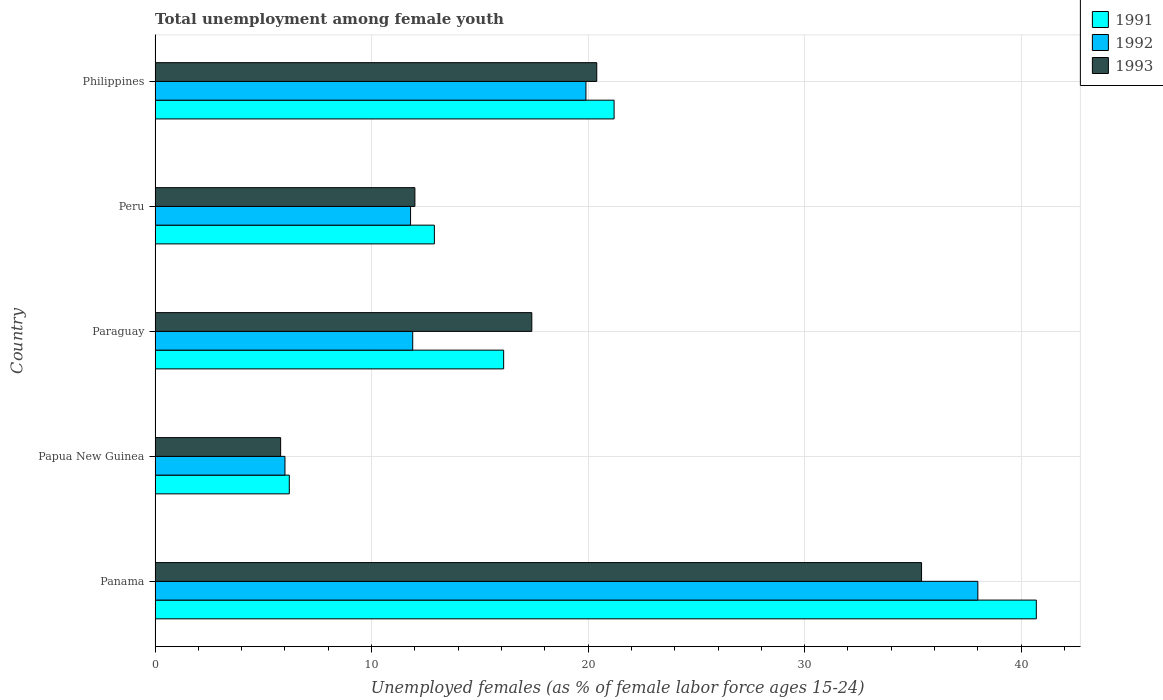How many different coloured bars are there?
Your answer should be compact. 3. How many groups of bars are there?
Your response must be concise. 5. Are the number of bars on each tick of the Y-axis equal?
Your answer should be very brief. Yes. How many bars are there on the 1st tick from the top?
Make the answer very short. 3. What is the label of the 2nd group of bars from the top?
Offer a very short reply. Peru. In how many cases, is the number of bars for a given country not equal to the number of legend labels?
Give a very brief answer. 0. What is the percentage of unemployed females in in 1992 in Paraguay?
Your response must be concise. 11.9. Across all countries, what is the maximum percentage of unemployed females in in 1991?
Your response must be concise. 40.7. Across all countries, what is the minimum percentage of unemployed females in in 1993?
Keep it short and to the point. 5.8. In which country was the percentage of unemployed females in in 1991 maximum?
Ensure brevity in your answer.  Panama. In which country was the percentage of unemployed females in in 1992 minimum?
Your answer should be compact. Papua New Guinea. What is the total percentage of unemployed females in in 1993 in the graph?
Offer a very short reply. 91. What is the difference between the percentage of unemployed females in in 1992 in Paraguay and that in Peru?
Offer a terse response. 0.1. What is the difference between the percentage of unemployed females in in 1992 in Peru and the percentage of unemployed females in in 1991 in Philippines?
Keep it short and to the point. -9.4. What is the average percentage of unemployed females in in 1991 per country?
Your response must be concise. 19.42. What is the difference between the percentage of unemployed females in in 1992 and percentage of unemployed females in in 1993 in Philippines?
Your answer should be very brief. -0.5. In how many countries, is the percentage of unemployed females in in 1993 greater than 16 %?
Make the answer very short. 3. What is the ratio of the percentage of unemployed females in in 1992 in Panama to that in Philippines?
Provide a short and direct response. 1.91. Is the percentage of unemployed females in in 1993 in Paraguay less than that in Peru?
Provide a succinct answer. No. Is the difference between the percentage of unemployed females in in 1992 in Paraguay and Peru greater than the difference between the percentage of unemployed females in in 1993 in Paraguay and Peru?
Make the answer very short. No. What is the difference between the highest and the second highest percentage of unemployed females in in 1991?
Offer a very short reply. 19.5. What is the difference between the highest and the lowest percentage of unemployed females in in 1993?
Your answer should be compact. 29.6. In how many countries, is the percentage of unemployed females in in 1993 greater than the average percentage of unemployed females in in 1993 taken over all countries?
Offer a terse response. 2. Is the sum of the percentage of unemployed females in in 1992 in Papua New Guinea and Philippines greater than the maximum percentage of unemployed females in in 1991 across all countries?
Provide a short and direct response. No. What does the 2nd bar from the top in Panama represents?
Your answer should be compact. 1992. Is it the case that in every country, the sum of the percentage of unemployed females in in 1991 and percentage of unemployed females in in 1992 is greater than the percentage of unemployed females in in 1993?
Provide a succinct answer. Yes. Are the values on the major ticks of X-axis written in scientific E-notation?
Make the answer very short. No. Does the graph contain grids?
Keep it short and to the point. Yes. How many legend labels are there?
Your response must be concise. 3. What is the title of the graph?
Your answer should be compact. Total unemployment among female youth. What is the label or title of the X-axis?
Keep it short and to the point. Unemployed females (as % of female labor force ages 15-24). What is the label or title of the Y-axis?
Your answer should be compact. Country. What is the Unemployed females (as % of female labor force ages 15-24) of 1991 in Panama?
Your answer should be very brief. 40.7. What is the Unemployed females (as % of female labor force ages 15-24) in 1992 in Panama?
Ensure brevity in your answer.  38. What is the Unemployed females (as % of female labor force ages 15-24) of 1993 in Panama?
Ensure brevity in your answer.  35.4. What is the Unemployed females (as % of female labor force ages 15-24) in 1991 in Papua New Guinea?
Provide a succinct answer. 6.2. What is the Unemployed females (as % of female labor force ages 15-24) in 1993 in Papua New Guinea?
Your answer should be compact. 5.8. What is the Unemployed females (as % of female labor force ages 15-24) in 1991 in Paraguay?
Your response must be concise. 16.1. What is the Unemployed females (as % of female labor force ages 15-24) in 1992 in Paraguay?
Ensure brevity in your answer.  11.9. What is the Unemployed females (as % of female labor force ages 15-24) in 1993 in Paraguay?
Offer a terse response. 17.4. What is the Unemployed females (as % of female labor force ages 15-24) of 1991 in Peru?
Ensure brevity in your answer.  12.9. What is the Unemployed females (as % of female labor force ages 15-24) of 1992 in Peru?
Offer a terse response. 11.8. What is the Unemployed females (as % of female labor force ages 15-24) in 1991 in Philippines?
Make the answer very short. 21.2. What is the Unemployed females (as % of female labor force ages 15-24) of 1992 in Philippines?
Offer a very short reply. 19.9. What is the Unemployed females (as % of female labor force ages 15-24) of 1993 in Philippines?
Ensure brevity in your answer.  20.4. Across all countries, what is the maximum Unemployed females (as % of female labor force ages 15-24) in 1991?
Your response must be concise. 40.7. Across all countries, what is the maximum Unemployed females (as % of female labor force ages 15-24) in 1992?
Give a very brief answer. 38. Across all countries, what is the maximum Unemployed females (as % of female labor force ages 15-24) of 1993?
Offer a very short reply. 35.4. Across all countries, what is the minimum Unemployed females (as % of female labor force ages 15-24) of 1991?
Keep it short and to the point. 6.2. Across all countries, what is the minimum Unemployed females (as % of female labor force ages 15-24) of 1993?
Make the answer very short. 5.8. What is the total Unemployed females (as % of female labor force ages 15-24) in 1991 in the graph?
Keep it short and to the point. 97.1. What is the total Unemployed females (as % of female labor force ages 15-24) in 1992 in the graph?
Make the answer very short. 87.6. What is the total Unemployed females (as % of female labor force ages 15-24) in 1993 in the graph?
Provide a short and direct response. 91. What is the difference between the Unemployed females (as % of female labor force ages 15-24) in 1991 in Panama and that in Papua New Guinea?
Offer a very short reply. 34.5. What is the difference between the Unemployed females (as % of female labor force ages 15-24) in 1992 in Panama and that in Papua New Guinea?
Ensure brevity in your answer.  32. What is the difference between the Unemployed females (as % of female labor force ages 15-24) in 1993 in Panama and that in Papua New Guinea?
Ensure brevity in your answer.  29.6. What is the difference between the Unemployed females (as % of female labor force ages 15-24) of 1991 in Panama and that in Paraguay?
Offer a very short reply. 24.6. What is the difference between the Unemployed females (as % of female labor force ages 15-24) in 1992 in Panama and that in Paraguay?
Your answer should be compact. 26.1. What is the difference between the Unemployed females (as % of female labor force ages 15-24) in 1993 in Panama and that in Paraguay?
Make the answer very short. 18. What is the difference between the Unemployed females (as % of female labor force ages 15-24) of 1991 in Panama and that in Peru?
Ensure brevity in your answer.  27.8. What is the difference between the Unemployed females (as % of female labor force ages 15-24) of 1992 in Panama and that in Peru?
Offer a very short reply. 26.2. What is the difference between the Unemployed females (as % of female labor force ages 15-24) in 1993 in Panama and that in Peru?
Make the answer very short. 23.4. What is the difference between the Unemployed females (as % of female labor force ages 15-24) of 1991 in Papua New Guinea and that in Paraguay?
Ensure brevity in your answer.  -9.9. What is the difference between the Unemployed females (as % of female labor force ages 15-24) of 1992 in Papua New Guinea and that in Paraguay?
Your answer should be compact. -5.9. What is the difference between the Unemployed females (as % of female labor force ages 15-24) in 1993 in Papua New Guinea and that in Paraguay?
Provide a succinct answer. -11.6. What is the difference between the Unemployed females (as % of female labor force ages 15-24) of 1992 in Papua New Guinea and that in Peru?
Make the answer very short. -5.8. What is the difference between the Unemployed females (as % of female labor force ages 15-24) in 1993 in Papua New Guinea and that in Peru?
Your response must be concise. -6.2. What is the difference between the Unemployed females (as % of female labor force ages 15-24) in 1991 in Papua New Guinea and that in Philippines?
Your response must be concise. -15. What is the difference between the Unemployed females (as % of female labor force ages 15-24) of 1993 in Papua New Guinea and that in Philippines?
Make the answer very short. -14.6. What is the difference between the Unemployed females (as % of female labor force ages 15-24) in 1991 in Paraguay and that in Peru?
Offer a very short reply. 3.2. What is the difference between the Unemployed females (as % of female labor force ages 15-24) in 1993 in Paraguay and that in Peru?
Keep it short and to the point. 5.4. What is the difference between the Unemployed females (as % of female labor force ages 15-24) of 1991 in Paraguay and that in Philippines?
Your answer should be compact. -5.1. What is the difference between the Unemployed females (as % of female labor force ages 15-24) in 1993 in Paraguay and that in Philippines?
Your answer should be very brief. -3. What is the difference between the Unemployed females (as % of female labor force ages 15-24) of 1991 in Peru and that in Philippines?
Keep it short and to the point. -8.3. What is the difference between the Unemployed females (as % of female labor force ages 15-24) in 1992 in Peru and that in Philippines?
Ensure brevity in your answer.  -8.1. What is the difference between the Unemployed females (as % of female labor force ages 15-24) in 1993 in Peru and that in Philippines?
Provide a short and direct response. -8.4. What is the difference between the Unemployed females (as % of female labor force ages 15-24) of 1991 in Panama and the Unemployed females (as % of female labor force ages 15-24) of 1992 in Papua New Guinea?
Your response must be concise. 34.7. What is the difference between the Unemployed females (as % of female labor force ages 15-24) of 1991 in Panama and the Unemployed females (as % of female labor force ages 15-24) of 1993 in Papua New Guinea?
Your answer should be very brief. 34.9. What is the difference between the Unemployed females (as % of female labor force ages 15-24) of 1992 in Panama and the Unemployed females (as % of female labor force ages 15-24) of 1993 in Papua New Guinea?
Your response must be concise. 32.2. What is the difference between the Unemployed females (as % of female labor force ages 15-24) in 1991 in Panama and the Unemployed females (as % of female labor force ages 15-24) in 1992 in Paraguay?
Your answer should be very brief. 28.8. What is the difference between the Unemployed females (as % of female labor force ages 15-24) in 1991 in Panama and the Unemployed females (as % of female labor force ages 15-24) in 1993 in Paraguay?
Provide a succinct answer. 23.3. What is the difference between the Unemployed females (as % of female labor force ages 15-24) in 1992 in Panama and the Unemployed females (as % of female labor force ages 15-24) in 1993 in Paraguay?
Offer a very short reply. 20.6. What is the difference between the Unemployed females (as % of female labor force ages 15-24) in 1991 in Panama and the Unemployed females (as % of female labor force ages 15-24) in 1992 in Peru?
Keep it short and to the point. 28.9. What is the difference between the Unemployed females (as % of female labor force ages 15-24) in 1991 in Panama and the Unemployed females (as % of female labor force ages 15-24) in 1993 in Peru?
Provide a short and direct response. 28.7. What is the difference between the Unemployed females (as % of female labor force ages 15-24) in 1992 in Panama and the Unemployed females (as % of female labor force ages 15-24) in 1993 in Peru?
Give a very brief answer. 26. What is the difference between the Unemployed females (as % of female labor force ages 15-24) in 1991 in Panama and the Unemployed females (as % of female labor force ages 15-24) in 1992 in Philippines?
Offer a terse response. 20.8. What is the difference between the Unemployed females (as % of female labor force ages 15-24) of 1991 in Panama and the Unemployed females (as % of female labor force ages 15-24) of 1993 in Philippines?
Your answer should be very brief. 20.3. What is the difference between the Unemployed females (as % of female labor force ages 15-24) of 1992 in Panama and the Unemployed females (as % of female labor force ages 15-24) of 1993 in Philippines?
Your answer should be compact. 17.6. What is the difference between the Unemployed females (as % of female labor force ages 15-24) in 1992 in Papua New Guinea and the Unemployed females (as % of female labor force ages 15-24) in 1993 in Paraguay?
Your answer should be compact. -11.4. What is the difference between the Unemployed females (as % of female labor force ages 15-24) in 1991 in Papua New Guinea and the Unemployed females (as % of female labor force ages 15-24) in 1993 in Peru?
Ensure brevity in your answer.  -5.8. What is the difference between the Unemployed females (as % of female labor force ages 15-24) in 1992 in Papua New Guinea and the Unemployed females (as % of female labor force ages 15-24) in 1993 in Peru?
Offer a very short reply. -6. What is the difference between the Unemployed females (as % of female labor force ages 15-24) in 1991 in Papua New Guinea and the Unemployed females (as % of female labor force ages 15-24) in 1992 in Philippines?
Keep it short and to the point. -13.7. What is the difference between the Unemployed females (as % of female labor force ages 15-24) in 1991 in Papua New Guinea and the Unemployed females (as % of female labor force ages 15-24) in 1993 in Philippines?
Your response must be concise. -14.2. What is the difference between the Unemployed females (as % of female labor force ages 15-24) in 1992 in Papua New Guinea and the Unemployed females (as % of female labor force ages 15-24) in 1993 in Philippines?
Ensure brevity in your answer.  -14.4. What is the difference between the Unemployed females (as % of female labor force ages 15-24) of 1991 in Paraguay and the Unemployed females (as % of female labor force ages 15-24) of 1992 in Peru?
Keep it short and to the point. 4.3. What is the difference between the Unemployed females (as % of female labor force ages 15-24) in 1992 in Paraguay and the Unemployed females (as % of female labor force ages 15-24) in 1993 in Peru?
Ensure brevity in your answer.  -0.1. What is the average Unemployed females (as % of female labor force ages 15-24) of 1991 per country?
Ensure brevity in your answer.  19.42. What is the average Unemployed females (as % of female labor force ages 15-24) of 1992 per country?
Provide a succinct answer. 17.52. What is the average Unemployed females (as % of female labor force ages 15-24) in 1993 per country?
Your response must be concise. 18.2. What is the difference between the Unemployed females (as % of female labor force ages 15-24) of 1991 and Unemployed females (as % of female labor force ages 15-24) of 1992 in Panama?
Ensure brevity in your answer.  2.7. What is the difference between the Unemployed females (as % of female labor force ages 15-24) of 1991 and Unemployed females (as % of female labor force ages 15-24) of 1993 in Panama?
Your answer should be very brief. 5.3. What is the difference between the Unemployed females (as % of female labor force ages 15-24) in 1991 and Unemployed females (as % of female labor force ages 15-24) in 1992 in Papua New Guinea?
Offer a very short reply. 0.2. What is the difference between the Unemployed females (as % of female labor force ages 15-24) in 1992 and Unemployed females (as % of female labor force ages 15-24) in 1993 in Papua New Guinea?
Give a very brief answer. 0.2. What is the difference between the Unemployed females (as % of female labor force ages 15-24) in 1991 and Unemployed females (as % of female labor force ages 15-24) in 1992 in Paraguay?
Make the answer very short. 4.2. What is the difference between the Unemployed females (as % of female labor force ages 15-24) in 1992 and Unemployed females (as % of female labor force ages 15-24) in 1993 in Peru?
Ensure brevity in your answer.  -0.2. What is the difference between the Unemployed females (as % of female labor force ages 15-24) in 1991 and Unemployed females (as % of female labor force ages 15-24) in 1992 in Philippines?
Your answer should be compact. 1.3. What is the ratio of the Unemployed females (as % of female labor force ages 15-24) in 1991 in Panama to that in Papua New Guinea?
Offer a terse response. 6.56. What is the ratio of the Unemployed females (as % of female labor force ages 15-24) in 1992 in Panama to that in Papua New Guinea?
Your response must be concise. 6.33. What is the ratio of the Unemployed females (as % of female labor force ages 15-24) in 1993 in Panama to that in Papua New Guinea?
Give a very brief answer. 6.1. What is the ratio of the Unemployed females (as % of female labor force ages 15-24) in 1991 in Panama to that in Paraguay?
Offer a terse response. 2.53. What is the ratio of the Unemployed females (as % of female labor force ages 15-24) of 1992 in Panama to that in Paraguay?
Make the answer very short. 3.19. What is the ratio of the Unemployed females (as % of female labor force ages 15-24) of 1993 in Panama to that in Paraguay?
Offer a very short reply. 2.03. What is the ratio of the Unemployed females (as % of female labor force ages 15-24) in 1991 in Panama to that in Peru?
Your answer should be compact. 3.15. What is the ratio of the Unemployed females (as % of female labor force ages 15-24) in 1992 in Panama to that in Peru?
Your answer should be compact. 3.22. What is the ratio of the Unemployed females (as % of female labor force ages 15-24) of 1993 in Panama to that in Peru?
Keep it short and to the point. 2.95. What is the ratio of the Unemployed females (as % of female labor force ages 15-24) of 1991 in Panama to that in Philippines?
Ensure brevity in your answer.  1.92. What is the ratio of the Unemployed females (as % of female labor force ages 15-24) in 1992 in Panama to that in Philippines?
Provide a short and direct response. 1.91. What is the ratio of the Unemployed females (as % of female labor force ages 15-24) of 1993 in Panama to that in Philippines?
Ensure brevity in your answer.  1.74. What is the ratio of the Unemployed females (as % of female labor force ages 15-24) of 1991 in Papua New Guinea to that in Paraguay?
Your answer should be very brief. 0.39. What is the ratio of the Unemployed females (as % of female labor force ages 15-24) in 1992 in Papua New Guinea to that in Paraguay?
Your answer should be very brief. 0.5. What is the ratio of the Unemployed females (as % of female labor force ages 15-24) in 1993 in Papua New Guinea to that in Paraguay?
Offer a very short reply. 0.33. What is the ratio of the Unemployed females (as % of female labor force ages 15-24) in 1991 in Papua New Guinea to that in Peru?
Keep it short and to the point. 0.48. What is the ratio of the Unemployed females (as % of female labor force ages 15-24) in 1992 in Papua New Guinea to that in Peru?
Make the answer very short. 0.51. What is the ratio of the Unemployed females (as % of female labor force ages 15-24) of 1993 in Papua New Guinea to that in Peru?
Keep it short and to the point. 0.48. What is the ratio of the Unemployed females (as % of female labor force ages 15-24) in 1991 in Papua New Guinea to that in Philippines?
Provide a short and direct response. 0.29. What is the ratio of the Unemployed females (as % of female labor force ages 15-24) of 1992 in Papua New Guinea to that in Philippines?
Offer a very short reply. 0.3. What is the ratio of the Unemployed females (as % of female labor force ages 15-24) in 1993 in Papua New Guinea to that in Philippines?
Provide a short and direct response. 0.28. What is the ratio of the Unemployed females (as % of female labor force ages 15-24) of 1991 in Paraguay to that in Peru?
Your answer should be compact. 1.25. What is the ratio of the Unemployed females (as % of female labor force ages 15-24) of 1992 in Paraguay to that in Peru?
Offer a terse response. 1.01. What is the ratio of the Unemployed females (as % of female labor force ages 15-24) of 1993 in Paraguay to that in Peru?
Provide a short and direct response. 1.45. What is the ratio of the Unemployed females (as % of female labor force ages 15-24) of 1991 in Paraguay to that in Philippines?
Provide a short and direct response. 0.76. What is the ratio of the Unemployed females (as % of female labor force ages 15-24) of 1992 in Paraguay to that in Philippines?
Make the answer very short. 0.6. What is the ratio of the Unemployed females (as % of female labor force ages 15-24) in 1993 in Paraguay to that in Philippines?
Your response must be concise. 0.85. What is the ratio of the Unemployed females (as % of female labor force ages 15-24) in 1991 in Peru to that in Philippines?
Your answer should be very brief. 0.61. What is the ratio of the Unemployed females (as % of female labor force ages 15-24) of 1992 in Peru to that in Philippines?
Offer a very short reply. 0.59. What is the ratio of the Unemployed females (as % of female labor force ages 15-24) in 1993 in Peru to that in Philippines?
Your answer should be compact. 0.59. What is the difference between the highest and the second highest Unemployed females (as % of female labor force ages 15-24) of 1993?
Offer a terse response. 15. What is the difference between the highest and the lowest Unemployed females (as % of female labor force ages 15-24) in 1991?
Your answer should be very brief. 34.5. What is the difference between the highest and the lowest Unemployed females (as % of female labor force ages 15-24) of 1992?
Ensure brevity in your answer.  32. What is the difference between the highest and the lowest Unemployed females (as % of female labor force ages 15-24) in 1993?
Offer a very short reply. 29.6. 